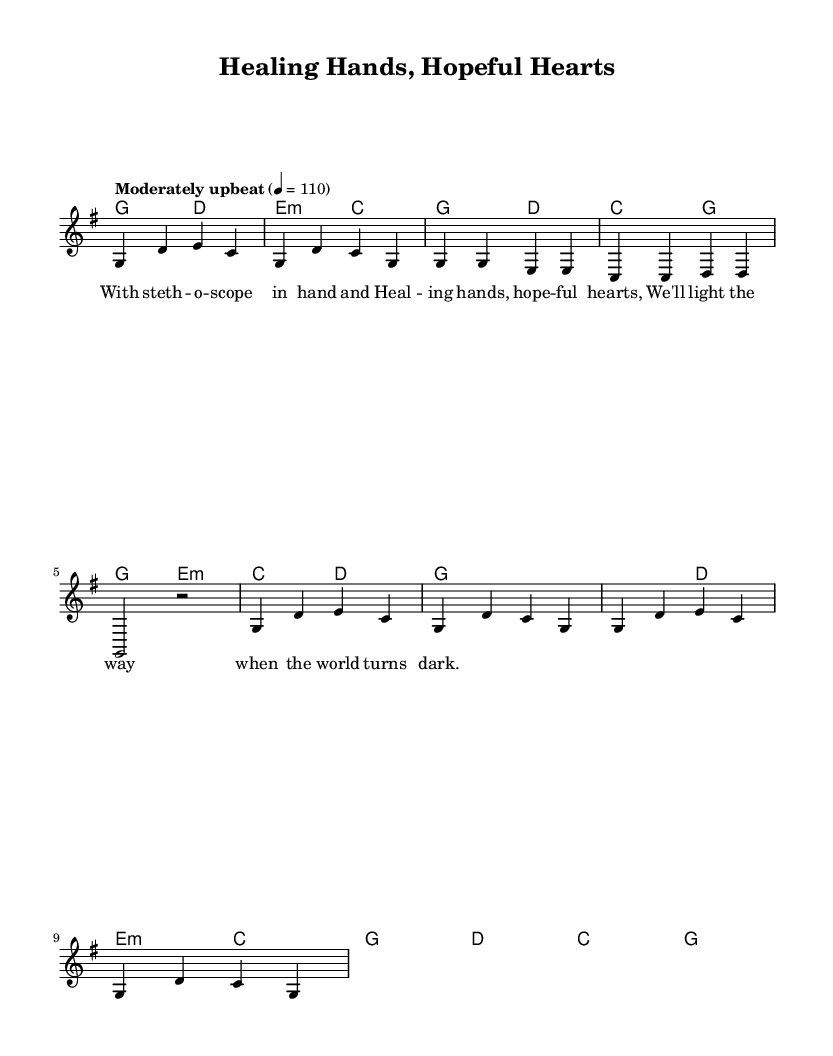What is the key signature of this music? The key signature is G major, which has one sharp (F#). This can be found at the beginning of the staff, indicating the tonal center of the piece.
Answer: G major What is the time signature of this music? The time signature is 4/4, which is indicated at the beginning of the score. This means there are four beats in each measure, with the quarter note getting one beat.
Answer: 4/4 What is the tempo marking for this piece? The tempo marking is "Moderately upbeat" set to 110 beats per minute. This is stated at the beginning of the score and indicates how fast the music should be played.
Answer: Moderately upbeat How many measures are in the chorus section? The chorus section consists of four measures. Counting the measures in the chorus part shown, we find that there are four separate measures.
Answer: 4 What is the theme expressed in the lyrics of the first verse? The theme expresses hope and healing in the medical profession. The lyrics reference using a stethoscope and highlight the importance of "healing hands" and "hopeful hearts."
Answer: Hope and healing What chord is used in the first measure? The chord used in the first measure is G major. The chord indicated at the start of the score next to the melody signifies that the harmony for the first measure is G major.
Answer: G major What is the poetic structure of the lyrics? The lyrics use a rhymed structure typical of folk music, reflecting a narrative quality with lines that emphasize healing and hope. This structure is common in folk anthems, supporting emotional themes.
Answer: Rhymed structure 